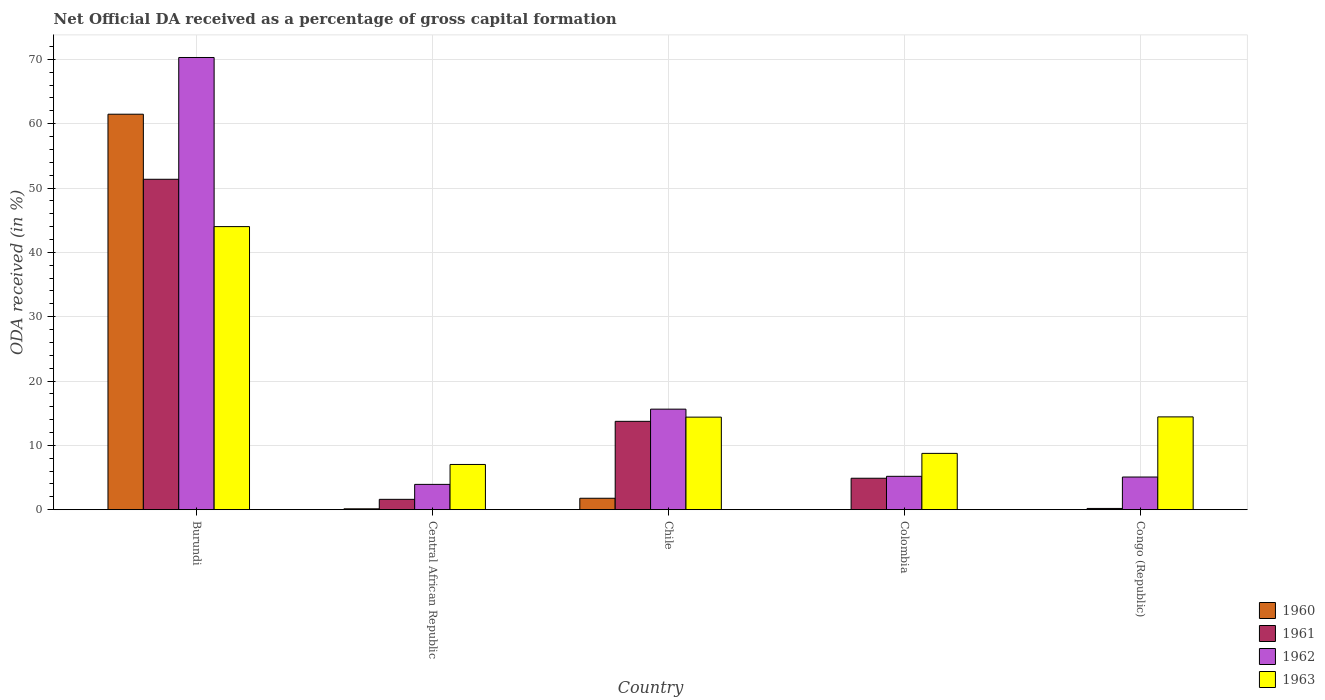How many different coloured bars are there?
Give a very brief answer. 4. Are the number of bars on each tick of the X-axis equal?
Your answer should be very brief. No. What is the net ODA received in 1963 in Chile?
Give a very brief answer. 14.39. Across all countries, what is the maximum net ODA received in 1961?
Provide a succinct answer. 51.36. In which country was the net ODA received in 1961 maximum?
Provide a short and direct response. Burundi. What is the total net ODA received in 1962 in the graph?
Provide a short and direct response. 100.11. What is the difference between the net ODA received in 1961 in Colombia and that in Congo (Republic)?
Keep it short and to the point. 4.7. What is the difference between the net ODA received in 1962 in Burundi and the net ODA received in 1961 in Colombia?
Your answer should be very brief. 65.4. What is the average net ODA received in 1962 per country?
Offer a very short reply. 20.02. What is the difference between the net ODA received of/in 1962 and net ODA received of/in 1961 in Congo (Republic)?
Provide a succinct answer. 4.89. What is the ratio of the net ODA received in 1961 in Burundi to that in Central African Republic?
Offer a terse response. 31.91. What is the difference between the highest and the second highest net ODA received in 1962?
Your answer should be very brief. -65.1. What is the difference between the highest and the lowest net ODA received in 1962?
Offer a very short reply. 66.35. In how many countries, is the net ODA received in 1960 greater than the average net ODA received in 1960 taken over all countries?
Your answer should be very brief. 1. Is it the case that in every country, the sum of the net ODA received in 1961 and net ODA received in 1960 is greater than the sum of net ODA received in 1963 and net ODA received in 1962?
Provide a succinct answer. No. How many countries are there in the graph?
Offer a terse response. 5. Are the values on the major ticks of Y-axis written in scientific E-notation?
Offer a very short reply. No. How many legend labels are there?
Give a very brief answer. 4. What is the title of the graph?
Your response must be concise. Net Official DA received as a percentage of gross capital formation. What is the label or title of the Y-axis?
Offer a terse response. ODA received (in %). What is the ODA received (in %) in 1960 in Burundi?
Offer a terse response. 61.47. What is the ODA received (in %) of 1961 in Burundi?
Provide a short and direct response. 51.36. What is the ODA received (in %) of 1962 in Burundi?
Give a very brief answer. 70.29. What is the ODA received (in %) in 1960 in Central African Republic?
Ensure brevity in your answer.  0.14. What is the ODA received (in %) of 1961 in Central African Republic?
Provide a short and direct response. 1.61. What is the ODA received (in %) in 1962 in Central African Republic?
Your answer should be compact. 3.93. What is the ODA received (in %) of 1963 in Central African Republic?
Provide a succinct answer. 7.03. What is the ODA received (in %) of 1960 in Chile?
Keep it short and to the point. 1.78. What is the ODA received (in %) of 1961 in Chile?
Provide a short and direct response. 13.73. What is the ODA received (in %) in 1962 in Chile?
Your response must be concise. 15.63. What is the ODA received (in %) of 1963 in Chile?
Offer a very short reply. 14.39. What is the ODA received (in %) of 1960 in Colombia?
Your answer should be very brief. 0. What is the ODA received (in %) of 1961 in Colombia?
Ensure brevity in your answer.  4.89. What is the ODA received (in %) in 1962 in Colombia?
Provide a short and direct response. 5.19. What is the ODA received (in %) of 1963 in Colombia?
Provide a short and direct response. 8.75. What is the ODA received (in %) of 1960 in Congo (Republic)?
Provide a short and direct response. 0.03. What is the ODA received (in %) in 1961 in Congo (Republic)?
Your answer should be compact. 0.19. What is the ODA received (in %) in 1962 in Congo (Republic)?
Your answer should be very brief. 5.08. What is the ODA received (in %) in 1963 in Congo (Republic)?
Make the answer very short. 14.43. Across all countries, what is the maximum ODA received (in %) in 1960?
Keep it short and to the point. 61.47. Across all countries, what is the maximum ODA received (in %) in 1961?
Ensure brevity in your answer.  51.36. Across all countries, what is the maximum ODA received (in %) in 1962?
Keep it short and to the point. 70.29. Across all countries, what is the maximum ODA received (in %) of 1963?
Provide a succinct answer. 44. Across all countries, what is the minimum ODA received (in %) in 1960?
Your response must be concise. 0. Across all countries, what is the minimum ODA received (in %) in 1961?
Provide a succinct answer. 0.19. Across all countries, what is the minimum ODA received (in %) in 1962?
Ensure brevity in your answer.  3.93. Across all countries, what is the minimum ODA received (in %) in 1963?
Your answer should be compact. 7.03. What is the total ODA received (in %) in 1960 in the graph?
Provide a short and direct response. 63.41. What is the total ODA received (in %) in 1961 in the graph?
Keep it short and to the point. 71.78. What is the total ODA received (in %) in 1962 in the graph?
Offer a terse response. 100.11. What is the total ODA received (in %) of 1963 in the graph?
Your answer should be very brief. 88.6. What is the difference between the ODA received (in %) in 1960 in Burundi and that in Central African Republic?
Your answer should be very brief. 61.33. What is the difference between the ODA received (in %) in 1961 in Burundi and that in Central African Republic?
Offer a terse response. 49.75. What is the difference between the ODA received (in %) of 1962 in Burundi and that in Central African Republic?
Offer a terse response. 66.35. What is the difference between the ODA received (in %) in 1963 in Burundi and that in Central African Republic?
Provide a short and direct response. 36.97. What is the difference between the ODA received (in %) in 1960 in Burundi and that in Chile?
Your response must be concise. 59.69. What is the difference between the ODA received (in %) of 1961 in Burundi and that in Chile?
Offer a terse response. 37.62. What is the difference between the ODA received (in %) of 1962 in Burundi and that in Chile?
Offer a terse response. 54.66. What is the difference between the ODA received (in %) in 1963 in Burundi and that in Chile?
Offer a terse response. 29.61. What is the difference between the ODA received (in %) in 1961 in Burundi and that in Colombia?
Offer a terse response. 46.47. What is the difference between the ODA received (in %) in 1962 in Burundi and that in Colombia?
Offer a terse response. 65.1. What is the difference between the ODA received (in %) in 1963 in Burundi and that in Colombia?
Give a very brief answer. 35.25. What is the difference between the ODA received (in %) of 1960 in Burundi and that in Congo (Republic)?
Provide a short and direct response. 61.44. What is the difference between the ODA received (in %) in 1961 in Burundi and that in Congo (Republic)?
Offer a very short reply. 51.16. What is the difference between the ODA received (in %) in 1962 in Burundi and that in Congo (Republic)?
Provide a succinct answer. 65.21. What is the difference between the ODA received (in %) of 1963 in Burundi and that in Congo (Republic)?
Make the answer very short. 29.57. What is the difference between the ODA received (in %) in 1960 in Central African Republic and that in Chile?
Give a very brief answer. -1.64. What is the difference between the ODA received (in %) of 1961 in Central African Republic and that in Chile?
Make the answer very short. -12.12. What is the difference between the ODA received (in %) in 1962 in Central African Republic and that in Chile?
Give a very brief answer. -11.7. What is the difference between the ODA received (in %) in 1963 in Central African Republic and that in Chile?
Ensure brevity in your answer.  -7.36. What is the difference between the ODA received (in %) of 1961 in Central African Republic and that in Colombia?
Provide a short and direct response. -3.28. What is the difference between the ODA received (in %) of 1962 in Central African Republic and that in Colombia?
Provide a succinct answer. -1.25. What is the difference between the ODA received (in %) of 1963 in Central African Republic and that in Colombia?
Make the answer very short. -1.72. What is the difference between the ODA received (in %) in 1960 in Central African Republic and that in Congo (Republic)?
Offer a very short reply. 0.11. What is the difference between the ODA received (in %) in 1961 in Central African Republic and that in Congo (Republic)?
Ensure brevity in your answer.  1.42. What is the difference between the ODA received (in %) of 1962 in Central African Republic and that in Congo (Republic)?
Your response must be concise. -1.15. What is the difference between the ODA received (in %) of 1963 in Central African Republic and that in Congo (Republic)?
Offer a terse response. -7.39. What is the difference between the ODA received (in %) of 1961 in Chile and that in Colombia?
Offer a terse response. 8.84. What is the difference between the ODA received (in %) in 1962 in Chile and that in Colombia?
Provide a succinct answer. 10.44. What is the difference between the ODA received (in %) of 1963 in Chile and that in Colombia?
Your answer should be very brief. 5.63. What is the difference between the ODA received (in %) of 1960 in Chile and that in Congo (Republic)?
Offer a very short reply. 1.75. What is the difference between the ODA received (in %) in 1961 in Chile and that in Congo (Republic)?
Your answer should be very brief. 13.54. What is the difference between the ODA received (in %) of 1962 in Chile and that in Congo (Republic)?
Make the answer very short. 10.55. What is the difference between the ODA received (in %) in 1963 in Chile and that in Congo (Republic)?
Your response must be concise. -0.04. What is the difference between the ODA received (in %) in 1961 in Colombia and that in Congo (Republic)?
Your response must be concise. 4.7. What is the difference between the ODA received (in %) of 1962 in Colombia and that in Congo (Republic)?
Ensure brevity in your answer.  0.11. What is the difference between the ODA received (in %) of 1963 in Colombia and that in Congo (Republic)?
Keep it short and to the point. -5.67. What is the difference between the ODA received (in %) of 1960 in Burundi and the ODA received (in %) of 1961 in Central African Republic?
Your answer should be very brief. 59.86. What is the difference between the ODA received (in %) in 1960 in Burundi and the ODA received (in %) in 1962 in Central African Republic?
Offer a very short reply. 57.54. What is the difference between the ODA received (in %) of 1960 in Burundi and the ODA received (in %) of 1963 in Central African Republic?
Offer a very short reply. 54.44. What is the difference between the ODA received (in %) of 1961 in Burundi and the ODA received (in %) of 1962 in Central African Republic?
Your answer should be compact. 47.42. What is the difference between the ODA received (in %) of 1961 in Burundi and the ODA received (in %) of 1963 in Central African Republic?
Your answer should be very brief. 44.33. What is the difference between the ODA received (in %) of 1962 in Burundi and the ODA received (in %) of 1963 in Central African Republic?
Your response must be concise. 63.25. What is the difference between the ODA received (in %) in 1960 in Burundi and the ODA received (in %) in 1961 in Chile?
Keep it short and to the point. 47.73. What is the difference between the ODA received (in %) in 1960 in Burundi and the ODA received (in %) in 1962 in Chile?
Keep it short and to the point. 45.84. What is the difference between the ODA received (in %) of 1960 in Burundi and the ODA received (in %) of 1963 in Chile?
Keep it short and to the point. 47.08. What is the difference between the ODA received (in %) in 1961 in Burundi and the ODA received (in %) in 1962 in Chile?
Make the answer very short. 35.73. What is the difference between the ODA received (in %) of 1961 in Burundi and the ODA received (in %) of 1963 in Chile?
Provide a short and direct response. 36.97. What is the difference between the ODA received (in %) in 1962 in Burundi and the ODA received (in %) in 1963 in Chile?
Keep it short and to the point. 55.9. What is the difference between the ODA received (in %) in 1960 in Burundi and the ODA received (in %) in 1961 in Colombia?
Provide a short and direct response. 56.58. What is the difference between the ODA received (in %) in 1960 in Burundi and the ODA received (in %) in 1962 in Colombia?
Your answer should be very brief. 56.28. What is the difference between the ODA received (in %) in 1960 in Burundi and the ODA received (in %) in 1963 in Colombia?
Provide a short and direct response. 52.72. What is the difference between the ODA received (in %) of 1961 in Burundi and the ODA received (in %) of 1962 in Colombia?
Offer a very short reply. 46.17. What is the difference between the ODA received (in %) of 1961 in Burundi and the ODA received (in %) of 1963 in Colombia?
Keep it short and to the point. 42.6. What is the difference between the ODA received (in %) in 1962 in Burundi and the ODA received (in %) in 1963 in Colombia?
Make the answer very short. 61.53. What is the difference between the ODA received (in %) in 1960 in Burundi and the ODA received (in %) in 1961 in Congo (Republic)?
Give a very brief answer. 61.28. What is the difference between the ODA received (in %) of 1960 in Burundi and the ODA received (in %) of 1962 in Congo (Republic)?
Your response must be concise. 56.39. What is the difference between the ODA received (in %) of 1960 in Burundi and the ODA received (in %) of 1963 in Congo (Republic)?
Your response must be concise. 47.04. What is the difference between the ODA received (in %) in 1961 in Burundi and the ODA received (in %) in 1962 in Congo (Republic)?
Offer a very short reply. 46.28. What is the difference between the ODA received (in %) in 1961 in Burundi and the ODA received (in %) in 1963 in Congo (Republic)?
Give a very brief answer. 36.93. What is the difference between the ODA received (in %) of 1962 in Burundi and the ODA received (in %) of 1963 in Congo (Republic)?
Your answer should be compact. 55.86. What is the difference between the ODA received (in %) of 1960 in Central African Republic and the ODA received (in %) of 1961 in Chile?
Give a very brief answer. -13.6. What is the difference between the ODA received (in %) of 1960 in Central African Republic and the ODA received (in %) of 1962 in Chile?
Offer a terse response. -15.49. What is the difference between the ODA received (in %) in 1960 in Central African Republic and the ODA received (in %) in 1963 in Chile?
Offer a very short reply. -14.25. What is the difference between the ODA received (in %) of 1961 in Central African Republic and the ODA received (in %) of 1962 in Chile?
Make the answer very short. -14.02. What is the difference between the ODA received (in %) in 1961 in Central African Republic and the ODA received (in %) in 1963 in Chile?
Provide a short and direct response. -12.78. What is the difference between the ODA received (in %) in 1962 in Central African Republic and the ODA received (in %) in 1963 in Chile?
Offer a terse response. -10.45. What is the difference between the ODA received (in %) in 1960 in Central African Republic and the ODA received (in %) in 1961 in Colombia?
Your response must be concise. -4.75. What is the difference between the ODA received (in %) in 1960 in Central African Republic and the ODA received (in %) in 1962 in Colombia?
Keep it short and to the point. -5.05. What is the difference between the ODA received (in %) of 1960 in Central African Republic and the ODA received (in %) of 1963 in Colombia?
Provide a succinct answer. -8.62. What is the difference between the ODA received (in %) of 1961 in Central African Republic and the ODA received (in %) of 1962 in Colombia?
Ensure brevity in your answer.  -3.58. What is the difference between the ODA received (in %) of 1961 in Central African Republic and the ODA received (in %) of 1963 in Colombia?
Give a very brief answer. -7.14. What is the difference between the ODA received (in %) in 1962 in Central African Republic and the ODA received (in %) in 1963 in Colombia?
Provide a succinct answer. -4.82. What is the difference between the ODA received (in %) in 1960 in Central African Republic and the ODA received (in %) in 1961 in Congo (Republic)?
Offer a terse response. -0.06. What is the difference between the ODA received (in %) of 1960 in Central African Republic and the ODA received (in %) of 1962 in Congo (Republic)?
Keep it short and to the point. -4.94. What is the difference between the ODA received (in %) of 1960 in Central African Republic and the ODA received (in %) of 1963 in Congo (Republic)?
Make the answer very short. -14.29. What is the difference between the ODA received (in %) of 1961 in Central African Republic and the ODA received (in %) of 1962 in Congo (Republic)?
Your answer should be compact. -3.47. What is the difference between the ODA received (in %) of 1961 in Central African Republic and the ODA received (in %) of 1963 in Congo (Republic)?
Offer a very short reply. -12.82. What is the difference between the ODA received (in %) in 1962 in Central African Republic and the ODA received (in %) in 1963 in Congo (Republic)?
Keep it short and to the point. -10.49. What is the difference between the ODA received (in %) of 1960 in Chile and the ODA received (in %) of 1961 in Colombia?
Ensure brevity in your answer.  -3.11. What is the difference between the ODA received (in %) in 1960 in Chile and the ODA received (in %) in 1962 in Colombia?
Provide a short and direct response. -3.41. What is the difference between the ODA received (in %) in 1960 in Chile and the ODA received (in %) in 1963 in Colombia?
Offer a terse response. -6.97. What is the difference between the ODA received (in %) of 1961 in Chile and the ODA received (in %) of 1962 in Colombia?
Your response must be concise. 8.55. What is the difference between the ODA received (in %) in 1961 in Chile and the ODA received (in %) in 1963 in Colombia?
Give a very brief answer. 4.98. What is the difference between the ODA received (in %) of 1962 in Chile and the ODA received (in %) of 1963 in Colombia?
Ensure brevity in your answer.  6.88. What is the difference between the ODA received (in %) in 1960 in Chile and the ODA received (in %) in 1961 in Congo (Republic)?
Make the answer very short. 1.59. What is the difference between the ODA received (in %) of 1960 in Chile and the ODA received (in %) of 1962 in Congo (Republic)?
Offer a very short reply. -3.3. What is the difference between the ODA received (in %) of 1960 in Chile and the ODA received (in %) of 1963 in Congo (Republic)?
Your answer should be compact. -12.65. What is the difference between the ODA received (in %) of 1961 in Chile and the ODA received (in %) of 1962 in Congo (Republic)?
Provide a short and direct response. 8.66. What is the difference between the ODA received (in %) in 1961 in Chile and the ODA received (in %) in 1963 in Congo (Republic)?
Provide a short and direct response. -0.69. What is the difference between the ODA received (in %) of 1962 in Chile and the ODA received (in %) of 1963 in Congo (Republic)?
Offer a terse response. 1.2. What is the difference between the ODA received (in %) of 1961 in Colombia and the ODA received (in %) of 1962 in Congo (Republic)?
Provide a succinct answer. -0.19. What is the difference between the ODA received (in %) of 1961 in Colombia and the ODA received (in %) of 1963 in Congo (Republic)?
Ensure brevity in your answer.  -9.54. What is the difference between the ODA received (in %) of 1962 in Colombia and the ODA received (in %) of 1963 in Congo (Republic)?
Offer a terse response. -9.24. What is the average ODA received (in %) in 1960 per country?
Ensure brevity in your answer.  12.68. What is the average ODA received (in %) of 1961 per country?
Ensure brevity in your answer.  14.36. What is the average ODA received (in %) in 1962 per country?
Ensure brevity in your answer.  20.02. What is the average ODA received (in %) of 1963 per country?
Your answer should be very brief. 17.72. What is the difference between the ODA received (in %) of 1960 and ODA received (in %) of 1961 in Burundi?
Give a very brief answer. 10.11. What is the difference between the ODA received (in %) in 1960 and ODA received (in %) in 1962 in Burundi?
Provide a succinct answer. -8.82. What is the difference between the ODA received (in %) in 1960 and ODA received (in %) in 1963 in Burundi?
Provide a succinct answer. 17.47. What is the difference between the ODA received (in %) of 1961 and ODA received (in %) of 1962 in Burundi?
Ensure brevity in your answer.  -18.93. What is the difference between the ODA received (in %) of 1961 and ODA received (in %) of 1963 in Burundi?
Provide a succinct answer. 7.36. What is the difference between the ODA received (in %) of 1962 and ODA received (in %) of 1963 in Burundi?
Keep it short and to the point. 26.29. What is the difference between the ODA received (in %) of 1960 and ODA received (in %) of 1961 in Central African Republic?
Make the answer very short. -1.47. What is the difference between the ODA received (in %) of 1960 and ODA received (in %) of 1962 in Central African Republic?
Offer a very short reply. -3.8. What is the difference between the ODA received (in %) of 1960 and ODA received (in %) of 1963 in Central African Republic?
Give a very brief answer. -6.89. What is the difference between the ODA received (in %) in 1961 and ODA received (in %) in 1962 in Central African Republic?
Ensure brevity in your answer.  -2.32. What is the difference between the ODA received (in %) in 1961 and ODA received (in %) in 1963 in Central African Republic?
Offer a terse response. -5.42. What is the difference between the ODA received (in %) of 1962 and ODA received (in %) of 1963 in Central African Republic?
Keep it short and to the point. -3.1. What is the difference between the ODA received (in %) in 1960 and ODA received (in %) in 1961 in Chile?
Make the answer very short. -11.96. What is the difference between the ODA received (in %) of 1960 and ODA received (in %) of 1962 in Chile?
Your answer should be very brief. -13.85. What is the difference between the ODA received (in %) in 1960 and ODA received (in %) in 1963 in Chile?
Make the answer very short. -12.61. What is the difference between the ODA received (in %) in 1961 and ODA received (in %) in 1962 in Chile?
Offer a terse response. -1.89. What is the difference between the ODA received (in %) in 1961 and ODA received (in %) in 1963 in Chile?
Ensure brevity in your answer.  -0.65. What is the difference between the ODA received (in %) of 1962 and ODA received (in %) of 1963 in Chile?
Keep it short and to the point. 1.24. What is the difference between the ODA received (in %) in 1961 and ODA received (in %) in 1962 in Colombia?
Keep it short and to the point. -0.3. What is the difference between the ODA received (in %) of 1961 and ODA received (in %) of 1963 in Colombia?
Offer a very short reply. -3.86. What is the difference between the ODA received (in %) of 1962 and ODA received (in %) of 1963 in Colombia?
Offer a terse response. -3.57. What is the difference between the ODA received (in %) in 1960 and ODA received (in %) in 1961 in Congo (Republic)?
Offer a very short reply. -0.17. What is the difference between the ODA received (in %) of 1960 and ODA received (in %) of 1962 in Congo (Republic)?
Provide a succinct answer. -5.05. What is the difference between the ODA received (in %) of 1960 and ODA received (in %) of 1963 in Congo (Republic)?
Provide a short and direct response. -14.4. What is the difference between the ODA received (in %) in 1961 and ODA received (in %) in 1962 in Congo (Republic)?
Provide a short and direct response. -4.89. What is the difference between the ODA received (in %) in 1961 and ODA received (in %) in 1963 in Congo (Republic)?
Your answer should be compact. -14.23. What is the difference between the ODA received (in %) in 1962 and ODA received (in %) in 1963 in Congo (Republic)?
Provide a short and direct response. -9.35. What is the ratio of the ODA received (in %) of 1960 in Burundi to that in Central African Republic?
Make the answer very short. 451.25. What is the ratio of the ODA received (in %) in 1961 in Burundi to that in Central African Republic?
Your response must be concise. 31.91. What is the ratio of the ODA received (in %) in 1962 in Burundi to that in Central African Republic?
Keep it short and to the point. 17.87. What is the ratio of the ODA received (in %) of 1963 in Burundi to that in Central African Republic?
Ensure brevity in your answer.  6.26. What is the ratio of the ODA received (in %) in 1960 in Burundi to that in Chile?
Provide a short and direct response. 34.55. What is the ratio of the ODA received (in %) in 1961 in Burundi to that in Chile?
Keep it short and to the point. 3.74. What is the ratio of the ODA received (in %) of 1962 in Burundi to that in Chile?
Your answer should be compact. 4.5. What is the ratio of the ODA received (in %) of 1963 in Burundi to that in Chile?
Make the answer very short. 3.06. What is the ratio of the ODA received (in %) of 1961 in Burundi to that in Colombia?
Your answer should be very brief. 10.5. What is the ratio of the ODA received (in %) of 1962 in Burundi to that in Colombia?
Your answer should be compact. 13.55. What is the ratio of the ODA received (in %) in 1963 in Burundi to that in Colombia?
Keep it short and to the point. 5.03. What is the ratio of the ODA received (in %) in 1960 in Burundi to that in Congo (Republic)?
Offer a terse response. 2153.4. What is the ratio of the ODA received (in %) of 1961 in Burundi to that in Congo (Republic)?
Give a very brief answer. 265.07. What is the ratio of the ODA received (in %) of 1962 in Burundi to that in Congo (Republic)?
Offer a terse response. 13.84. What is the ratio of the ODA received (in %) of 1963 in Burundi to that in Congo (Republic)?
Ensure brevity in your answer.  3.05. What is the ratio of the ODA received (in %) of 1960 in Central African Republic to that in Chile?
Your response must be concise. 0.08. What is the ratio of the ODA received (in %) in 1961 in Central African Republic to that in Chile?
Give a very brief answer. 0.12. What is the ratio of the ODA received (in %) in 1962 in Central African Republic to that in Chile?
Your response must be concise. 0.25. What is the ratio of the ODA received (in %) in 1963 in Central African Republic to that in Chile?
Provide a succinct answer. 0.49. What is the ratio of the ODA received (in %) of 1961 in Central African Republic to that in Colombia?
Make the answer very short. 0.33. What is the ratio of the ODA received (in %) in 1962 in Central African Republic to that in Colombia?
Offer a terse response. 0.76. What is the ratio of the ODA received (in %) in 1963 in Central African Republic to that in Colombia?
Provide a short and direct response. 0.8. What is the ratio of the ODA received (in %) in 1960 in Central African Republic to that in Congo (Republic)?
Give a very brief answer. 4.77. What is the ratio of the ODA received (in %) in 1961 in Central African Republic to that in Congo (Republic)?
Your answer should be compact. 8.31. What is the ratio of the ODA received (in %) in 1962 in Central African Republic to that in Congo (Republic)?
Provide a short and direct response. 0.77. What is the ratio of the ODA received (in %) of 1963 in Central African Republic to that in Congo (Republic)?
Provide a short and direct response. 0.49. What is the ratio of the ODA received (in %) in 1961 in Chile to that in Colombia?
Your answer should be very brief. 2.81. What is the ratio of the ODA received (in %) in 1962 in Chile to that in Colombia?
Your answer should be very brief. 3.01. What is the ratio of the ODA received (in %) in 1963 in Chile to that in Colombia?
Ensure brevity in your answer.  1.64. What is the ratio of the ODA received (in %) in 1960 in Chile to that in Congo (Republic)?
Provide a succinct answer. 62.32. What is the ratio of the ODA received (in %) of 1961 in Chile to that in Congo (Republic)?
Provide a short and direct response. 70.89. What is the ratio of the ODA received (in %) of 1962 in Chile to that in Congo (Republic)?
Your answer should be compact. 3.08. What is the ratio of the ODA received (in %) of 1961 in Colombia to that in Congo (Republic)?
Make the answer very short. 25.24. What is the ratio of the ODA received (in %) in 1962 in Colombia to that in Congo (Republic)?
Provide a short and direct response. 1.02. What is the ratio of the ODA received (in %) of 1963 in Colombia to that in Congo (Republic)?
Provide a short and direct response. 0.61. What is the difference between the highest and the second highest ODA received (in %) of 1960?
Your answer should be compact. 59.69. What is the difference between the highest and the second highest ODA received (in %) in 1961?
Keep it short and to the point. 37.62. What is the difference between the highest and the second highest ODA received (in %) in 1962?
Provide a short and direct response. 54.66. What is the difference between the highest and the second highest ODA received (in %) of 1963?
Keep it short and to the point. 29.57. What is the difference between the highest and the lowest ODA received (in %) of 1960?
Provide a short and direct response. 61.47. What is the difference between the highest and the lowest ODA received (in %) of 1961?
Your answer should be compact. 51.16. What is the difference between the highest and the lowest ODA received (in %) of 1962?
Provide a short and direct response. 66.35. What is the difference between the highest and the lowest ODA received (in %) of 1963?
Provide a succinct answer. 36.97. 